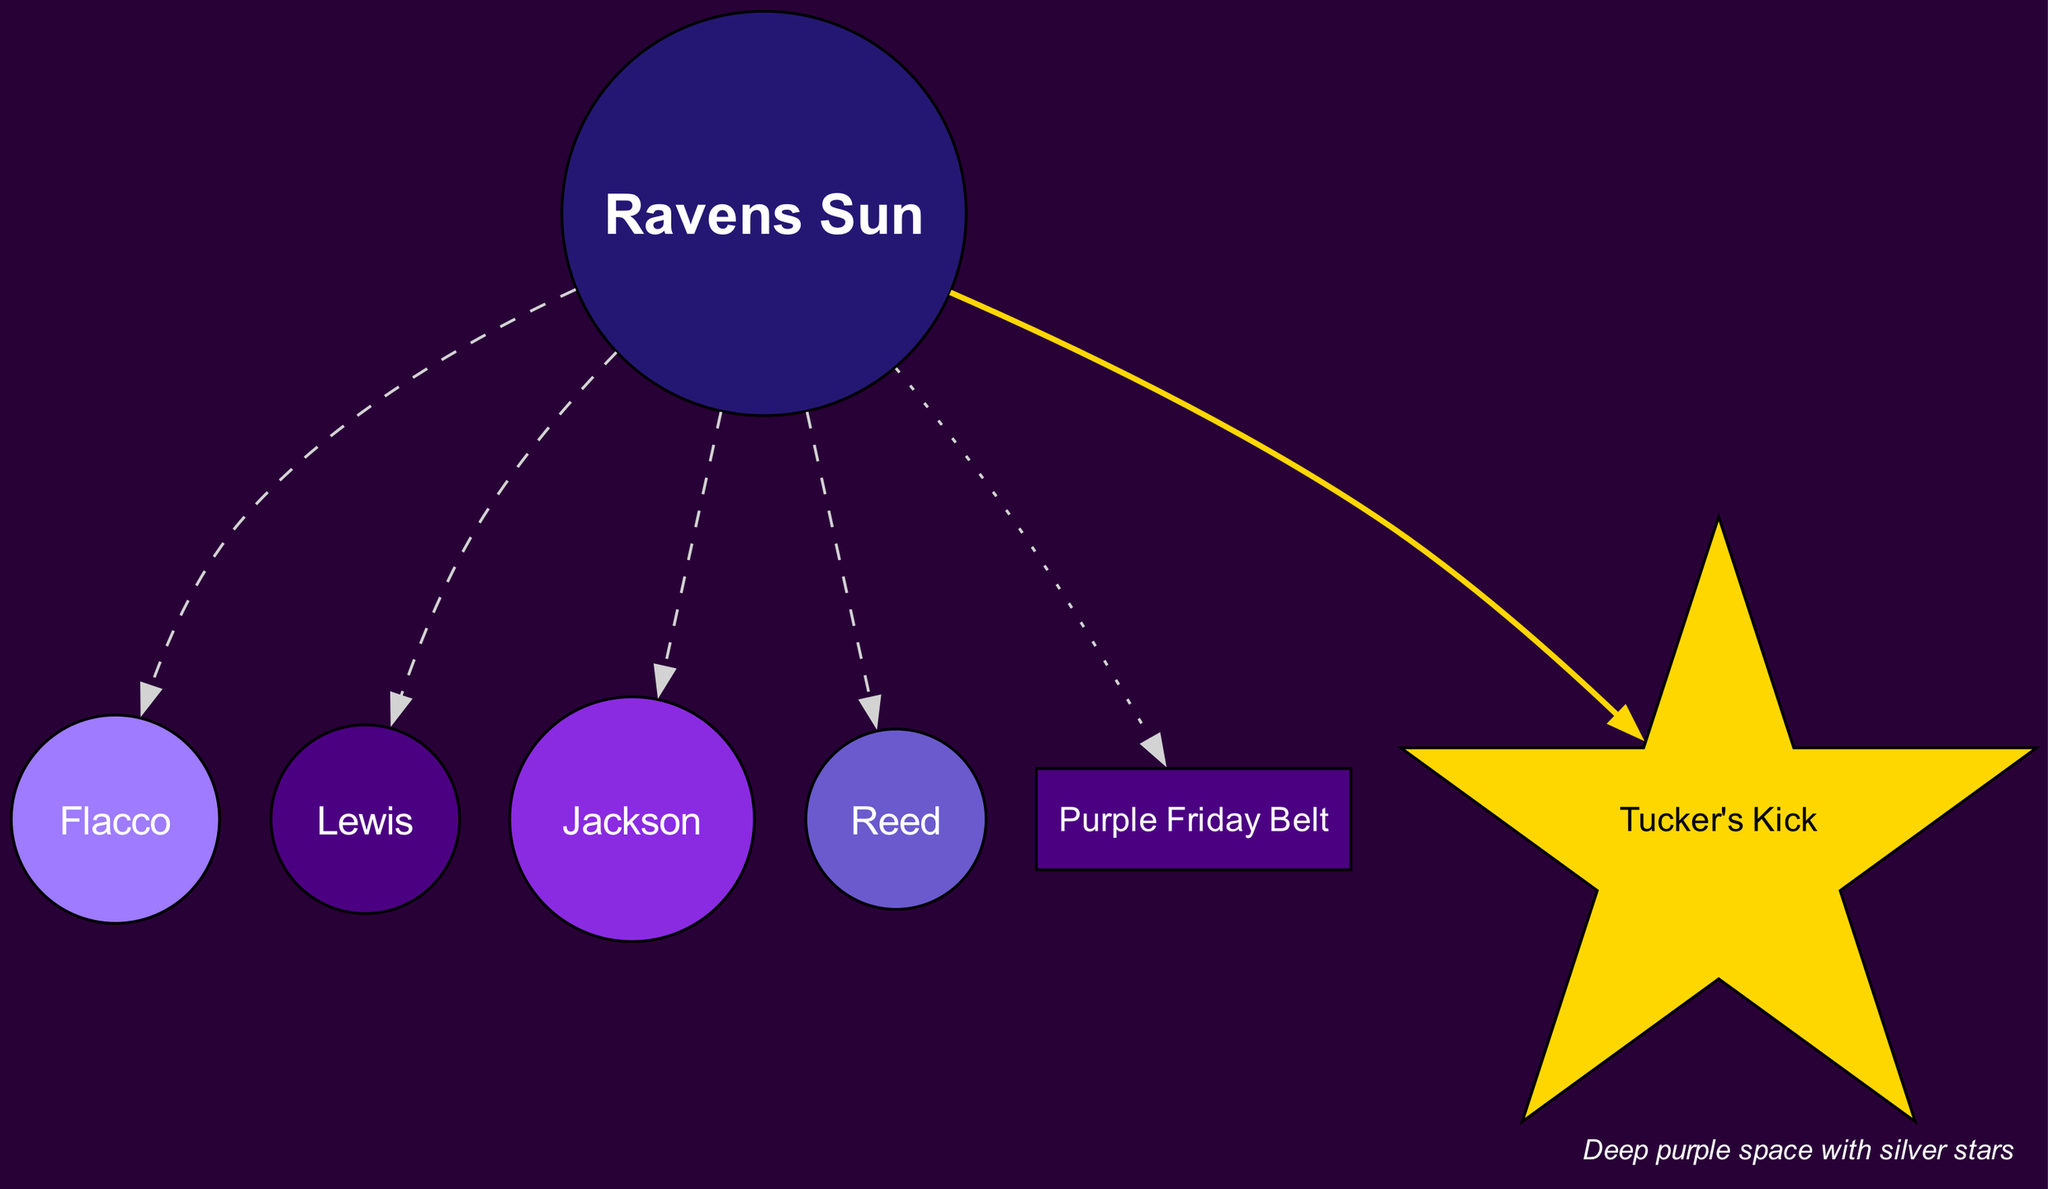What is the central element of the solar system in the diagram? The central element is marked as the "Ravens Sun," which is represented by the Baltimore Ravens logo. This is the focal point of the diagram, similar to how the sun serves in a traditional solar system.
Answer: Ravens Sun How many planets are represented in the solar system diagram? The diagram includes a total of four planets; they are Flacco, Lewis, Jackson, and Reed. Each is distinct and orbits the central Ravens Sun.
Answer: 4 Which planet represents QB Lamar Jackson in the diagram? The planet named "Jackson" represents QB Lamar Jackson. The diagram labels and connects this planet to the Ravens Sun, clearly indicating its identity.
Answer: Jackson What is the name of the asteroid belt in the diagram? The asteroid belt is named the "Purple Friday Belt." This labeling is specifically shown as an element distinct from the planets and the central sun.
Answer: Purple Friday Belt Which celestial object in the diagram is shaped like a star? The object that is shaped like a star is named "Tucker's Kick." It is visually distinct, and the star shape denotes its special significance related to Justin Tucker's field goals.
Answer: Tucker's Kick What color are the planets in the diagram? The planets are colored in shades of purple: Flacco is a light purple, Lewis is a darker purple, Jackson differs with a vibrant blue, and Reed is a blueish purple. Each color is visually distinctive and serves to differentiate the planets.
Answer: Shades of purple What is represented by the comet in the diagram? The comet named "Tucker's Kick" represents Justin Tucker's long-range field goals. This connection displays recognition for his talents and contributions to the team, indicated by the comet's name in the diagram.
Answer: Long-range field goals Which planet is a ringed planet in the diagram? The planet referred to as a ringed planet is "Reed." The description specifies it honors safety Ed Reed and visually represents it as different, setting it apart from the others.
Answer: Reed What is the background color of the diagram? The background color of the diagram is deep purple, creating a thematic connection with the Baltimore Ravens. The stars are silver, providing a contrast against this deep purple backdrop.
Answer: Deep purple 